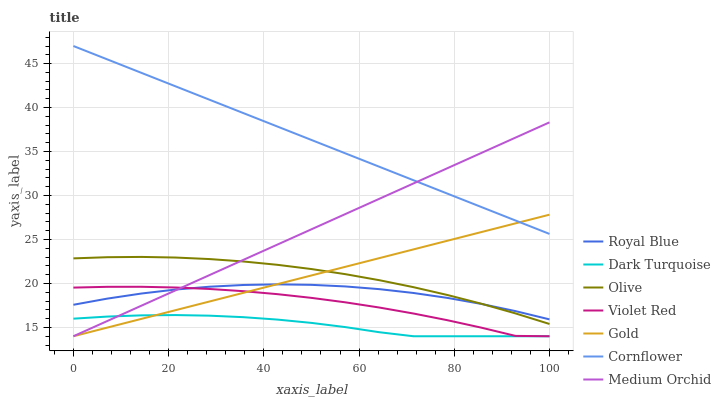Does Dark Turquoise have the minimum area under the curve?
Answer yes or no. Yes. Does Cornflower have the maximum area under the curve?
Answer yes or no. Yes. Does Violet Red have the minimum area under the curve?
Answer yes or no. No. Does Violet Red have the maximum area under the curve?
Answer yes or no. No. Is Gold the smoothest?
Answer yes or no. Yes. Is Violet Red the roughest?
Answer yes or no. Yes. Is Violet Red the smoothest?
Answer yes or no. No. Is Gold the roughest?
Answer yes or no. No. Does Violet Red have the lowest value?
Answer yes or no. Yes. Does Royal Blue have the lowest value?
Answer yes or no. No. Does Cornflower have the highest value?
Answer yes or no. Yes. Does Violet Red have the highest value?
Answer yes or no. No. Is Olive less than Cornflower?
Answer yes or no. Yes. Is Cornflower greater than Royal Blue?
Answer yes or no. Yes. Does Cornflower intersect Medium Orchid?
Answer yes or no. Yes. Is Cornflower less than Medium Orchid?
Answer yes or no. No. Is Cornflower greater than Medium Orchid?
Answer yes or no. No. Does Olive intersect Cornflower?
Answer yes or no. No. 